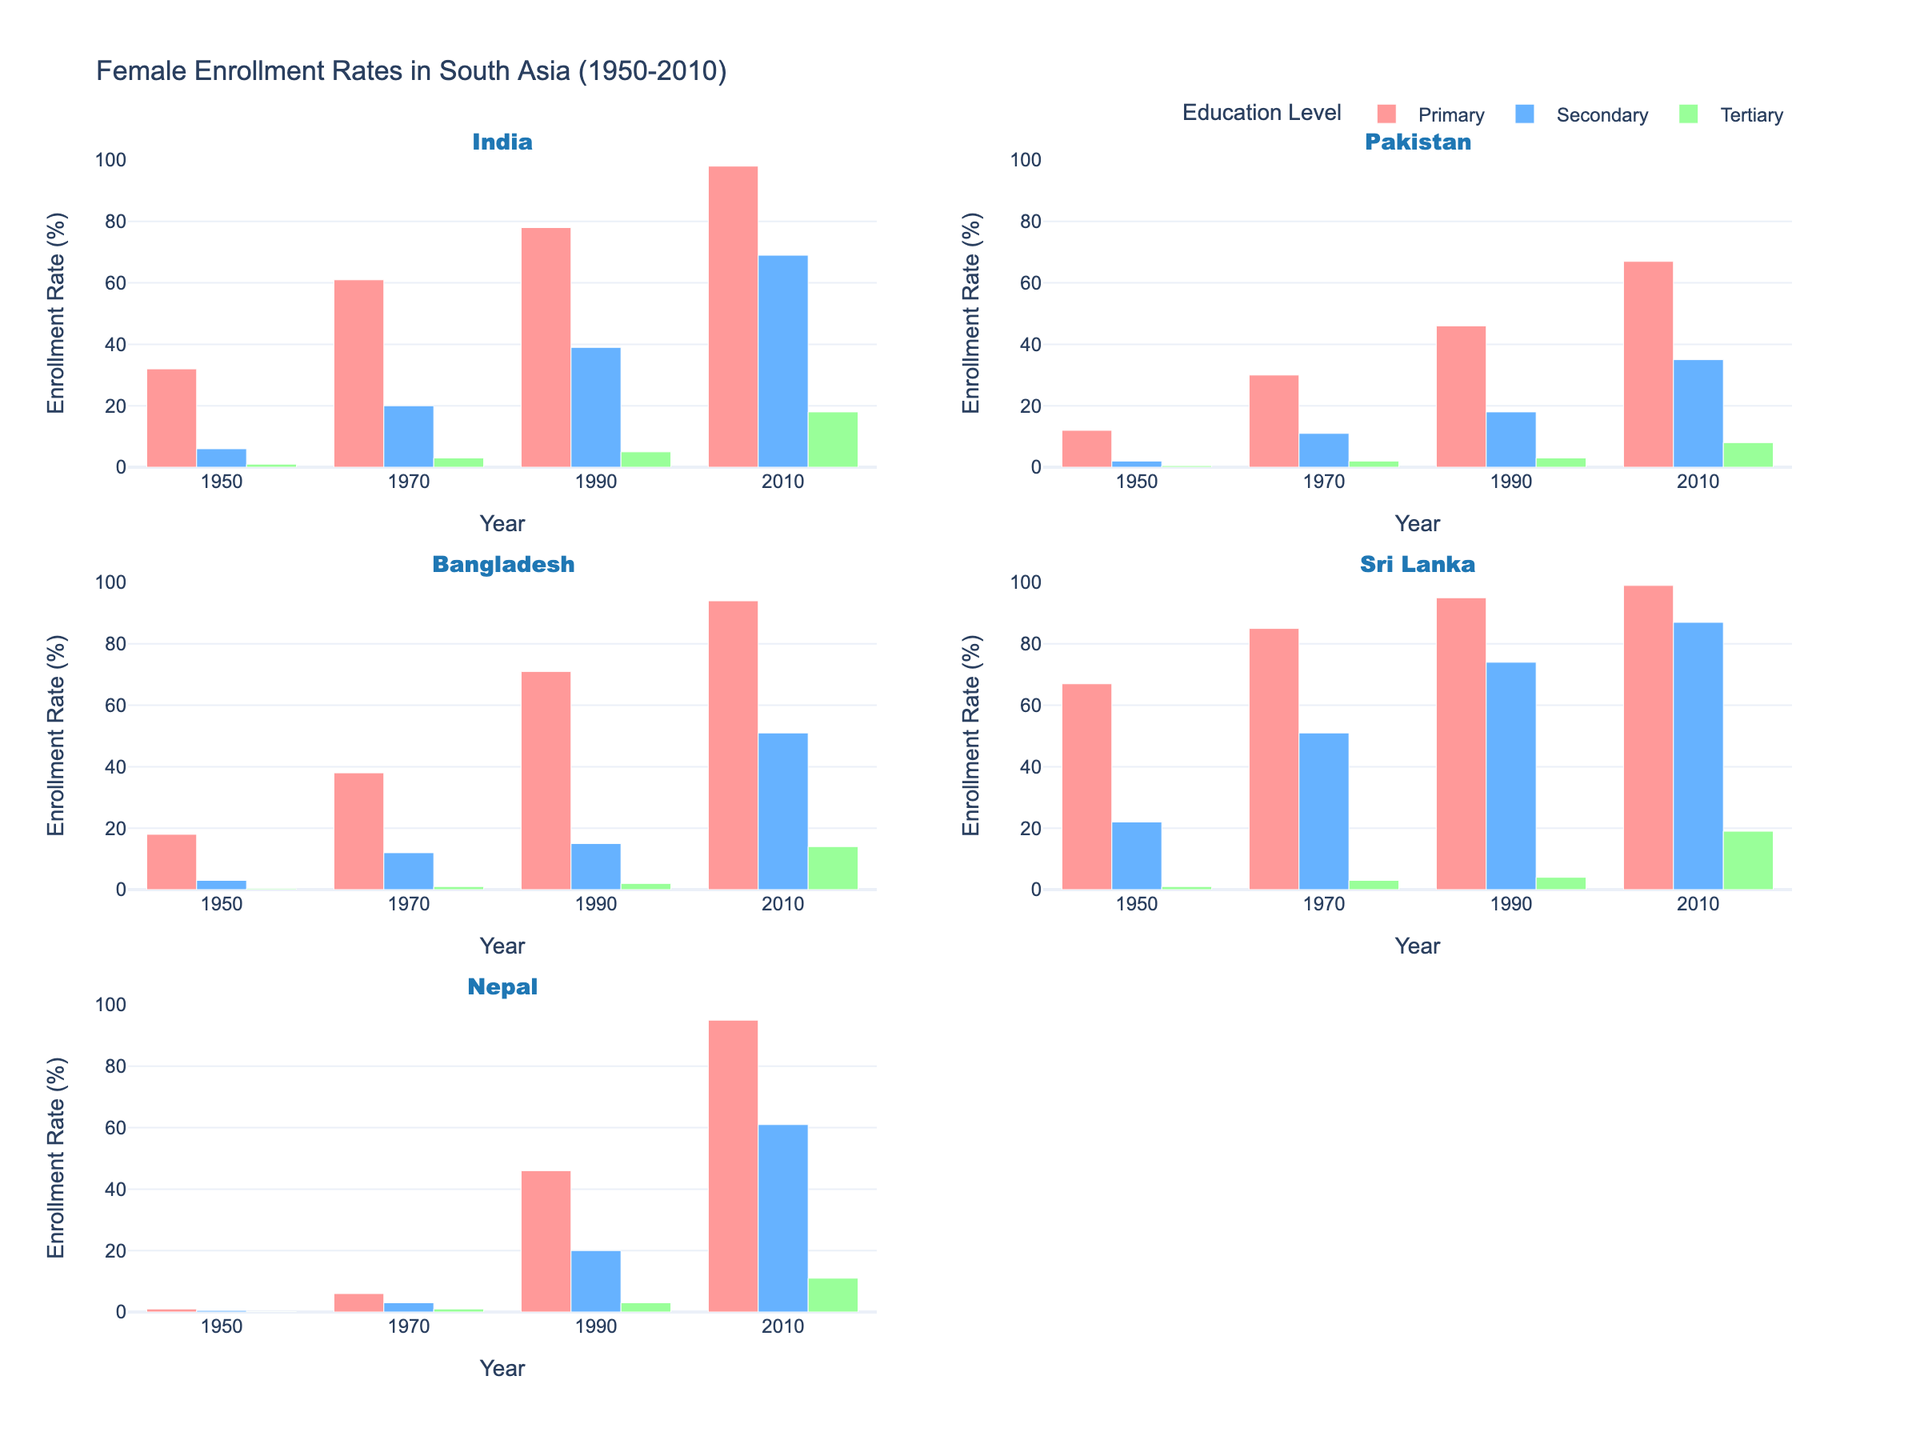What's the title of the figure? At the top of the figure, there is a main heading that reads "Female Enrollment Rates in South Asia (1950-2010)". This title summarizes the content of the entire figure.
Answer: Female Enrollment Rates in South Asia (1950-2010) How many countries are represented in the figure? Each subplot in the figure represents a different country. We see subplot titles for five countries: India, Pakistan, Bangladesh, Sri Lanka, and Nepal.
Answer: 5 What education level had the highest female enrollment rate in Sri Lanka in 1950? In the Sri Lanka subplot, the three education levels—Primary, Secondary, and Tertiary—are represented by bars with different heights for each year. In 1950, the Primary education bar is the tallest.
Answer: Primary Which country showed the most improvement in primary enrollment rates from 1950 to 2010? By examining the difference in bar heights from 1950 to 2010 for the Primary education level in each subplot, we see that Nepal has the most significant increase, from 1% in 1950 to 95% in 2010.
Answer: Nepal What is the difference in tertiary enrollment rates between India and Pakistan in 2010? In the subplots for both India and Pakistan, find the heights of the Tertiary education bars in 2010. For India, it is 18%, and for Pakistan, it is 8%. The difference is 18% - 8% = 10%.
Answer: 10% Which country had the lowest secondary enrollment rate in 1970? By comparing the heights of the Secondary education bars for all countries in 1970, we observe that Nepal has the smallest bar, representing 3%.
Answer: Nepal What year did Bangladesh surpass 50% enrollment for primary education? In the Bangladesh subplot, observe the bar heights for Primary education. The bar for 1990 is over 50%, while the 1970 bar is under 50%.
Answer: 1990 Rank the countries by tertiary enrollment rates in 1990 from highest to lowest. By comparing the heights of the Tertiary education bars for all countries in 1990, we get: India (5%), Sri Lanka (4%), Pakistan (3%), Nepal (3%), and Bangladesh (2%).
Answer: 1. India, 2. Sri Lanka, 3. Pakistan, 3. Nepal, 5. Bangladesh In which country did secondary education enrollment grow the most between 1990 and 2010? By comparing the heights of the Secondary education bars in 1990 and 2010 for each country, Nepal shows the most significant growth, from 20% to 61%.
Answer: Nepal How did the primary enrollment rate in Bangladesh change from 1970 to 1990? In the Bangladesh subplot, the Primary education bar increased from 38% in 1970 to 71% in 1990. The change is 71% - 38% = 33%.
Answer: Increased by 33% 